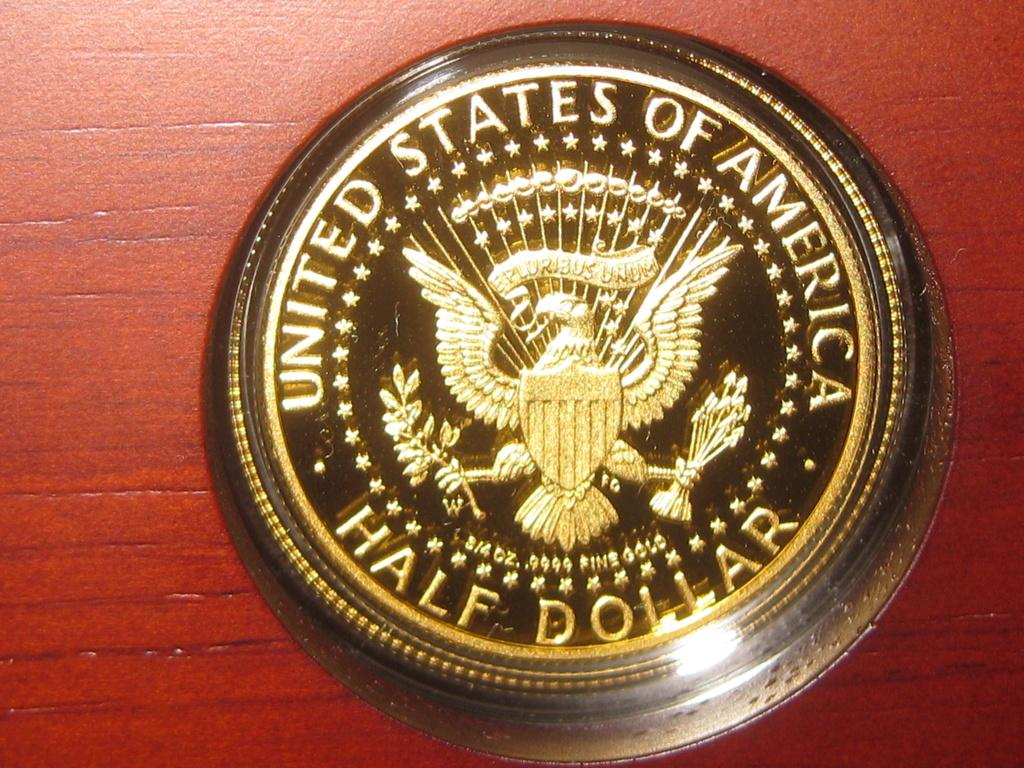<image>
Give a short and clear explanation of the subsequent image. A gold United States of America half dollar. 